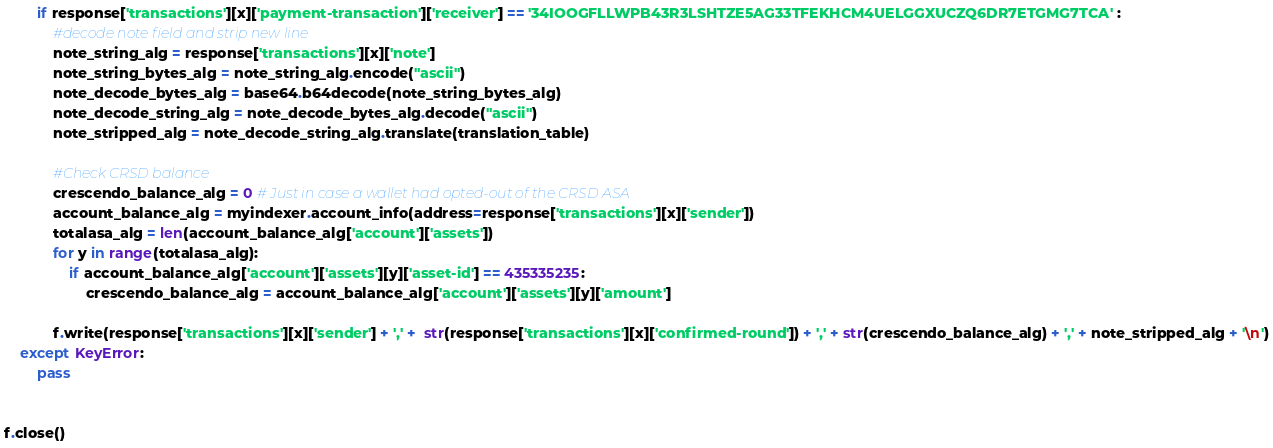<code> <loc_0><loc_0><loc_500><loc_500><_Python_>        if response['transactions'][x]['payment-transaction']['receiver'] == '34IOOGFLLWPB43R3LSHTZE5AG33TFEKHCM4UELGGXUCZQ6DR7ETGMG7TCA' :
            #decode note field and strip new line
            note_string_alg = response['transactions'][x]['note']
            note_string_bytes_alg = note_string_alg.encode("ascii")
            note_decode_bytes_alg = base64.b64decode(note_string_bytes_alg)
            note_decode_string_alg = note_decode_bytes_alg.decode("ascii")
            note_stripped_alg = note_decode_string_alg.translate(translation_table)

            #Check CRSD balance
            crescendo_balance_alg = 0 # Just in case a wallet had opted-out of the CRSD ASA
            account_balance_alg = myindexer.account_info(address=response['transactions'][x]['sender'])
            totalasa_alg = len(account_balance_alg['account']['assets'])
            for y in range(totalasa_alg):
                if account_balance_alg['account']['assets'][y]['asset-id'] == 435335235:
                    crescendo_balance_alg = account_balance_alg['account']['assets'][y]['amount']

            f.write(response['transactions'][x]['sender'] + ',' +  str(response['transactions'][x]['confirmed-round']) + ',' + str(crescendo_balance_alg) + ',' + note_stripped_alg + '\n')
    except KeyError:
        pass


f.close()
</code> 